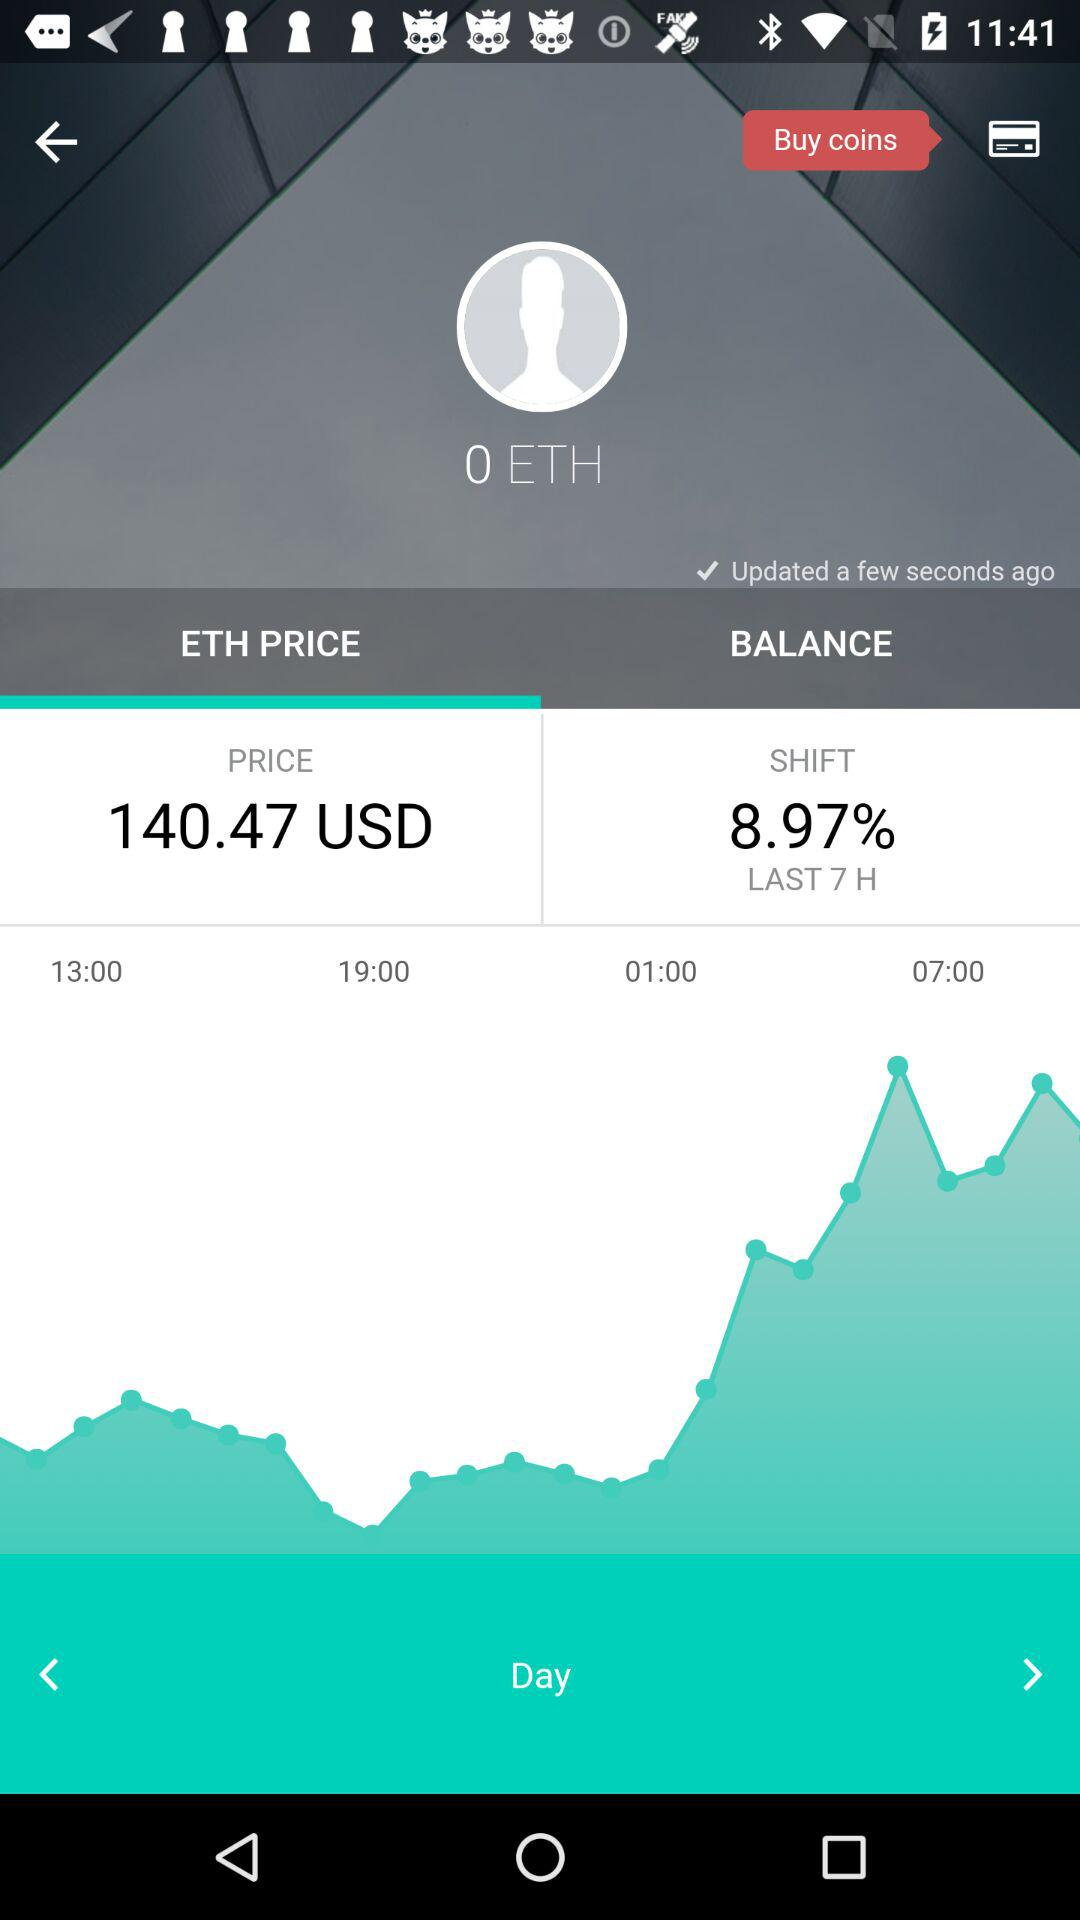What tab has been selected? The tab that has been selected is "ETH PRICE". 